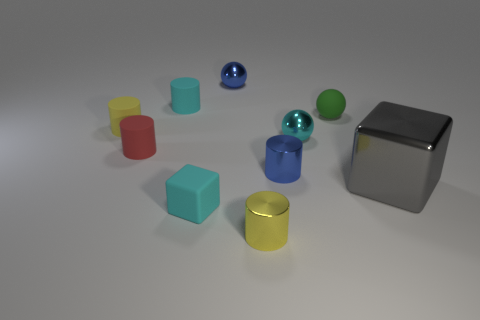Subtract all small cyan cylinders. How many cylinders are left? 4 Subtract all blue cylinders. How many cylinders are left? 4 Subtract all red cylinders. Subtract all brown cubes. How many cylinders are left? 4 Subtract all cubes. How many objects are left? 8 Subtract all small green matte cylinders. Subtract all blue things. How many objects are left? 8 Add 1 small yellow shiny cylinders. How many small yellow shiny cylinders are left? 2 Add 5 big purple metal cylinders. How many big purple metal cylinders exist? 5 Subtract 0 brown cylinders. How many objects are left? 10 